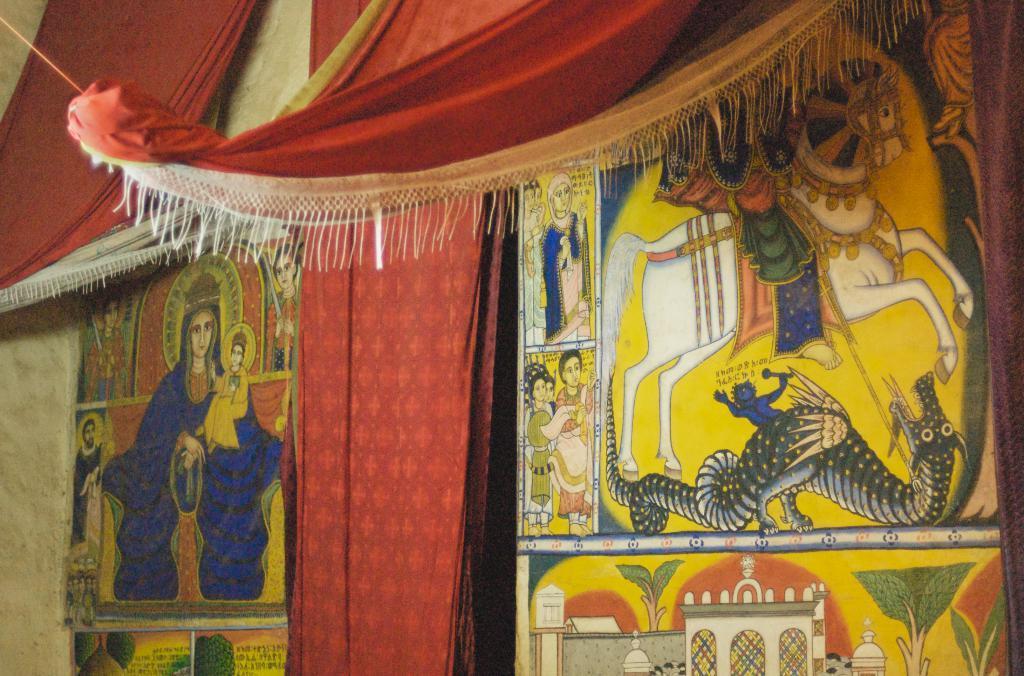Please provide a concise description of this image. In this image, I can see a clothes hanging, which are red in color. I think these are the wall paintings, which are drawn on the wall. 